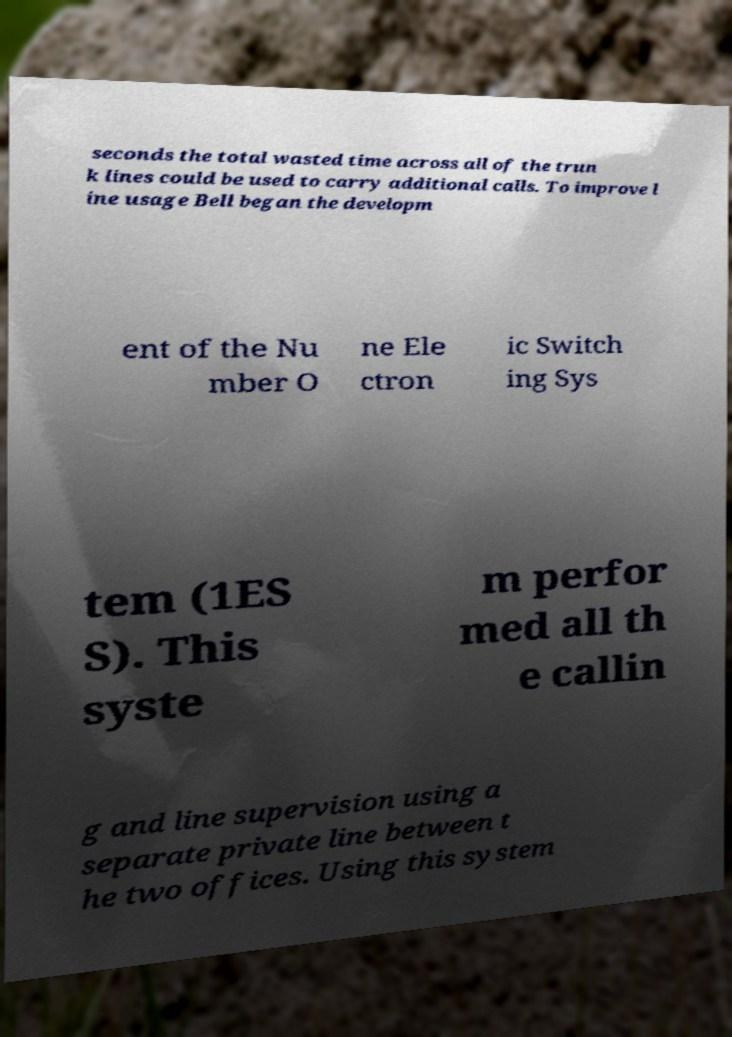Please identify and transcribe the text found in this image. seconds the total wasted time across all of the trun k lines could be used to carry additional calls. To improve l ine usage Bell began the developm ent of the Nu mber O ne Ele ctron ic Switch ing Sys tem (1ES S). This syste m perfor med all th e callin g and line supervision using a separate private line between t he two offices. Using this system 